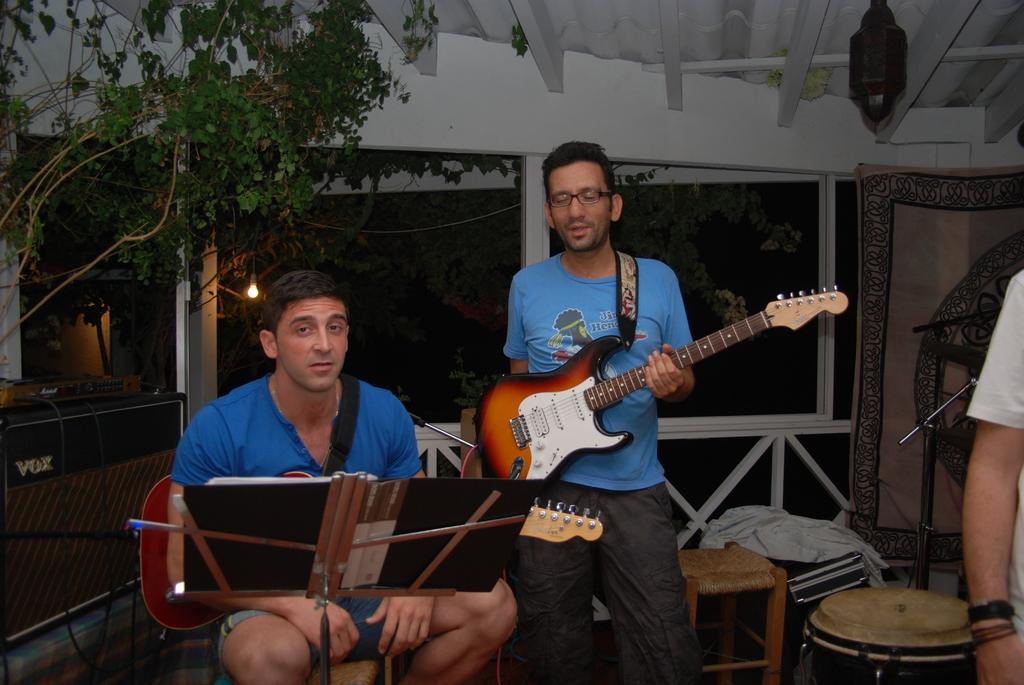How would you summarize this image in a sentence or two? In this image I see I see 3 men and 2 of them are standing and one of them is sitting and this man is holding a guitar. In the background I can see few stools, a cloth, few trees, a ceiling and the light. 